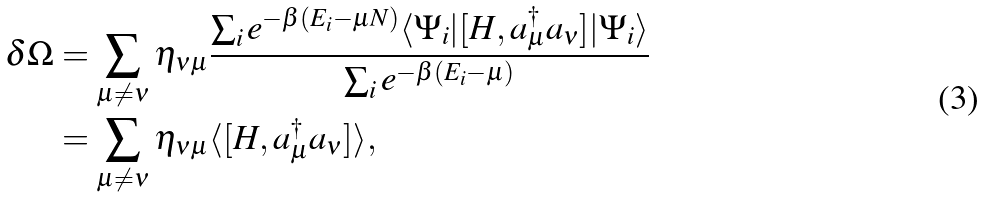Convert formula to latex. <formula><loc_0><loc_0><loc_500><loc_500>\delta \Omega & = \sum _ { \mu \ne \nu } \eta _ { \nu \mu } \frac { \sum _ { i } e ^ { - \beta ( E _ { i } - \mu N ) } \langle \Psi _ { i } | [ H , a ^ { \dagger } _ { \mu } a _ { \nu } ] | \Psi _ { i } \rangle } { \sum _ { i } e ^ { - \beta ( E _ { i } - \mu ) } } \\ & = \sum _ { \mu \ne \nu } \eta _ { \nu \mu } \langle [ H , a _ { \mu } ^ { \dagger } a _ { \nu } ] \rangle ,</formula> 